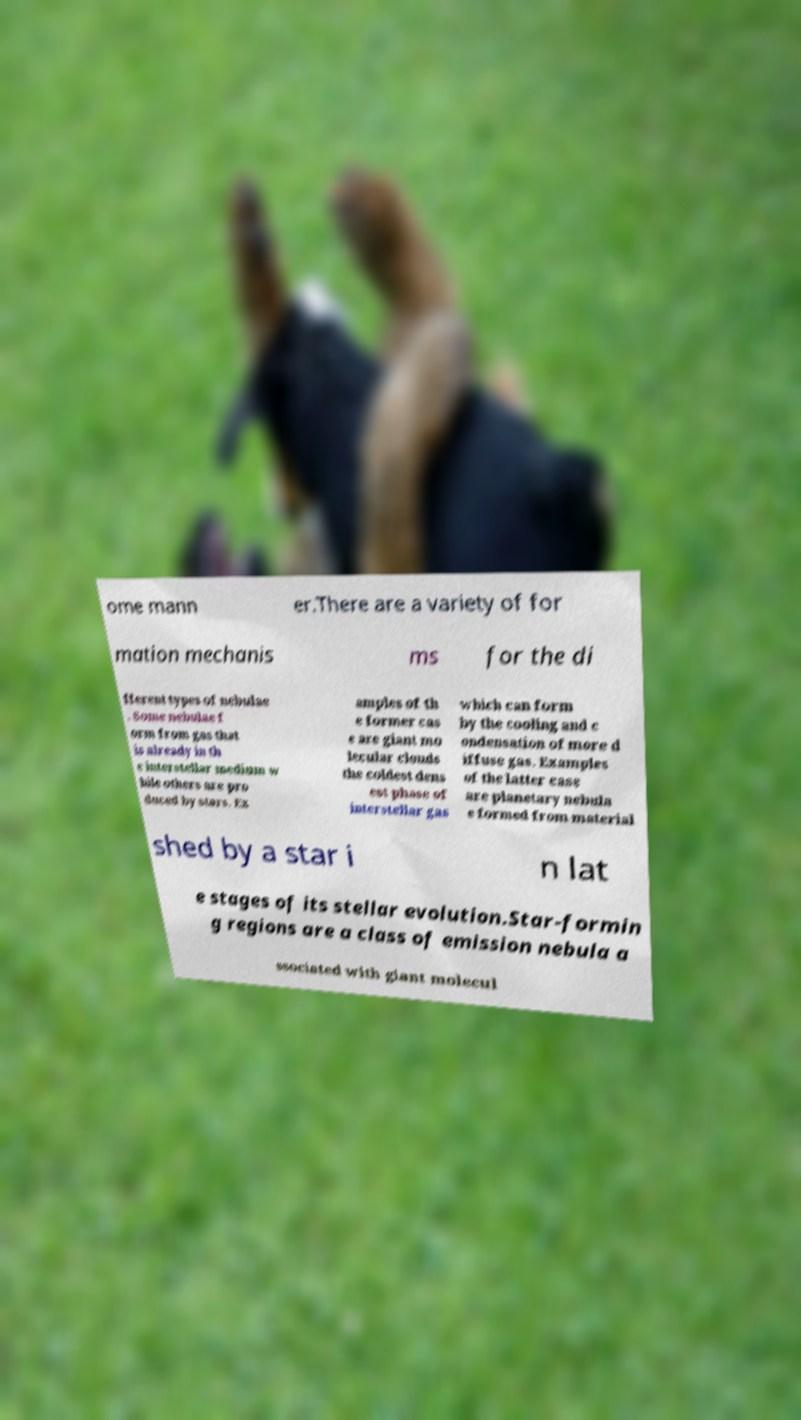Can you accurately transcribe the text from the provided image for me? ome mann er.There are a variety of for mation mechanis ms for the di fferent types of nebulae . Some nebulae f orm from gas that is already in th e interstellar medium w hile others are pro duced by stars. Ex amples of th e former cas e are giant mo lecular clouds the coldest dens est phase of interstellar gas which can form by the cooling and c ondensation of more d iffuse gas. Examples of the latter case are planetary nebula e formed from material shed by a star i n lat e stages of its stellar evolution.Star-formin g regions are a class of emission nebula a ssociated with giant molecul 